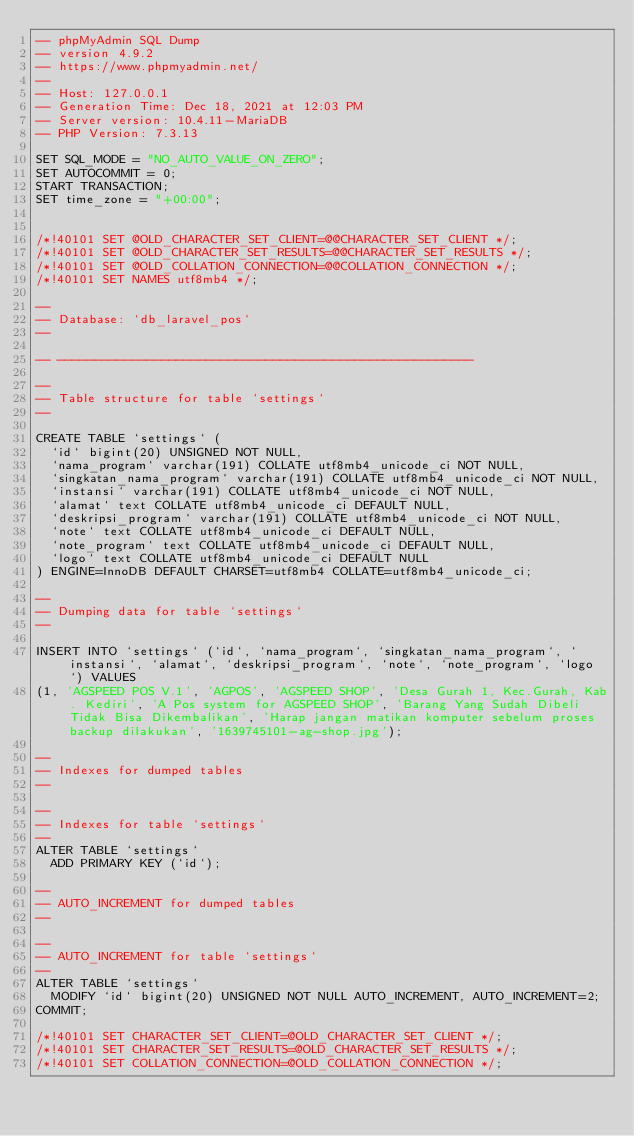Convert code to text. <code><loc_0><loc_0><loc_500><loc_500><_SQL_>-- phpMyAdmin SQL Dump
-- version 4.9.2
-- https://www.phpmyadmin.net/
--
-- Host: 127.0.0.1
-- Generation Time: Dec 18, 2021 at 12:03 PM
-- Server version: 10.4.11-MariaDB
-- PHP Version: 7.3.13

SET SQL_MODE = "NO_AUTO_VALUE_ON_ZERO";
SET AUTOCOMMIT = 0;
START TRANSACTION;
SET time_zone = "+00:00";


/*!40101 SET @OLD_CHARACTER_SET_CLIENT=@@CHARACTER_SET_CLIENT */;
/*!40101 SET @OLD_CHARACTER_SET_RESULTS=@@CHARACTER_SET_RESULTS */;
/*!40101 SET @OLD_COLLATION_CONNECTION=@@COLLATION_CONNECTION */;
/*!40101 SET NAMES utf8mb4 */;

--
-- Database: `db_laravel_pos`
--

-- --------------------------------------------------------

--
-- Table structure for table `settings`
--

CREATE TABLE `settings` (
  `id` bigint(20) UNSIGNED NOT NULL,
  `nama_program` varchar(191) COLLATE utf8mb4_unicode_ci NOT NULL,
  `singkatan_nama_program` varchar(191) COLLATE utf8mb4_unicode_ci NOT NULL,
  `instansi` varchar(191) COLLATE utf8mb4_unicode_ci NOT NULL,
  `alamat` text COLLATE utf8mb4_unicode_ci DEFAULT NULL,
  `deskripsi_program` varchar(191) COLLATE utf8mb4_unicode_ci NOT NULL,
  `note` text COLLATE utf8mb4_unicode_ci DEFAULT NULL,
  `note_program` text COLLATE utf8mb4_unicode_ci DEFAULT NULL,
  `logo` text COLLATE utf8mb4_unicode_ci DEFAULT NULL
) ENGINE=InnoDB DEFAULT CHARSET=utf8mb4 COLLATE=utf8mb4_unicode_ci;

--
-- Dumping data for table `settings`
--

INSERT INTO `settings` (`id`, `nama_program`, `singkatan_nama_program`, `instansi`, `alamat`, `deskripsi_program`, `note`, `note_program`, `logo`) VALUES
(1, 'AGSPEED POS V.1', 'AGPOS', 'AGSPEED SHOP', 'Desa Gurah 1, Kec.Gurah, Kab. Kediri', 'A Pos system for AGSPEED SHOP', 'Barang Yang Sudah Dibeli Tidak Bisa Dikembalikan', 'Harap jangan matikan komputer sebelum proses backup dilakukan', '1639745101-ag-shop.jpg');

--
-- Indexes for dumped tables
--

--
-- Indexes for table `settings`
--
ALTER TABLE `settings`
  ADD PRIMARY KEY (`id`);

--
-- AUTO_INCREMENT for dumped tables
--

--
-- AUTO_INCREMENT for table `settings`
--
ALTER TABLE `settings`
  MODIFY `id` bigint(20) UNSIGNED NOT NULL AUTO_INCREMENT, AUTO_INCREMENT=2;
COMMIT;

/*!40101 SET CHARACTER_SET_CLIENT=@OLD_CHARACTER_SET_CLIENT */;
/*!40101 SET CHARACTER_SET_RESULTS=@OLD_CHARACTER_SET_RESULTS */;
/*!40101 SET COLLATION_CONNECTION=@OLD_COLLATION_CONNECTION */;
</code> 